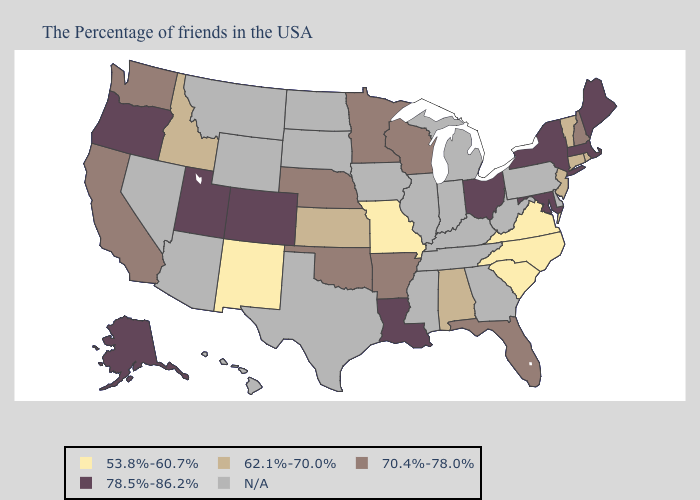Name the states that have a value in the range 78.5%-86.2%?
Quick response, please. Maine, Massachusetts, New York, Maryland, Ohio, Louisiana, Colorado, Utah, Oregon, Alaska. What is the highest value in states that border New York?
Give a very brief answer. 78.5%-86.2%. Does the map have missing data?
Be succinct. Yes. Which states have the lowest value in the USA?
Be succinct. Virginia, North Carolina, South Carolina, Missouri, New Mexico. Name the states that have a value in the range N/A?
Short answer required. Delaware, Pennsylvania, West Virginia, Georgia, Michigan, Kentucky, Indiana, Tennessee, Illinois, Mississippi, Iowa, Texas, South Dakota, North Dakota, Wyoming, Montana, Arizona, Nevada, Hawaii. What is the lowest value in the USA?
Concise answer only. 53.8%-60.7%. Does the first symbol in the legend represent the smallest category?
Quick response, please. Yes. What is the lowest value in the USA?
Quick response, please. 53.8%-60.7%. What is the value of Connecticut?
Give a very brief answer. 62.1%-70.0%. Name the states that have a value in the range 53.8%-60.7%?
Write a very short answer. Virginia, North Carolina, South Carolina, Missouri, New Mexico. Among the states that border Louisiana , which have the highest value?
Be succinct. Arkansas. What is the value of Arkansas?
Give a very brief answer. 70.4%-78.0%. Does the first symbol in the legend represent the smallest category?
Quick response, please. Yes. Name the states that have a value in the range 70.4%-78.0%?
Give a very brief answer. New Hampshire, Florida, Wisconsin, Arkansas, Minnesota, Nebraska, Oklahoma, California, Washington. 